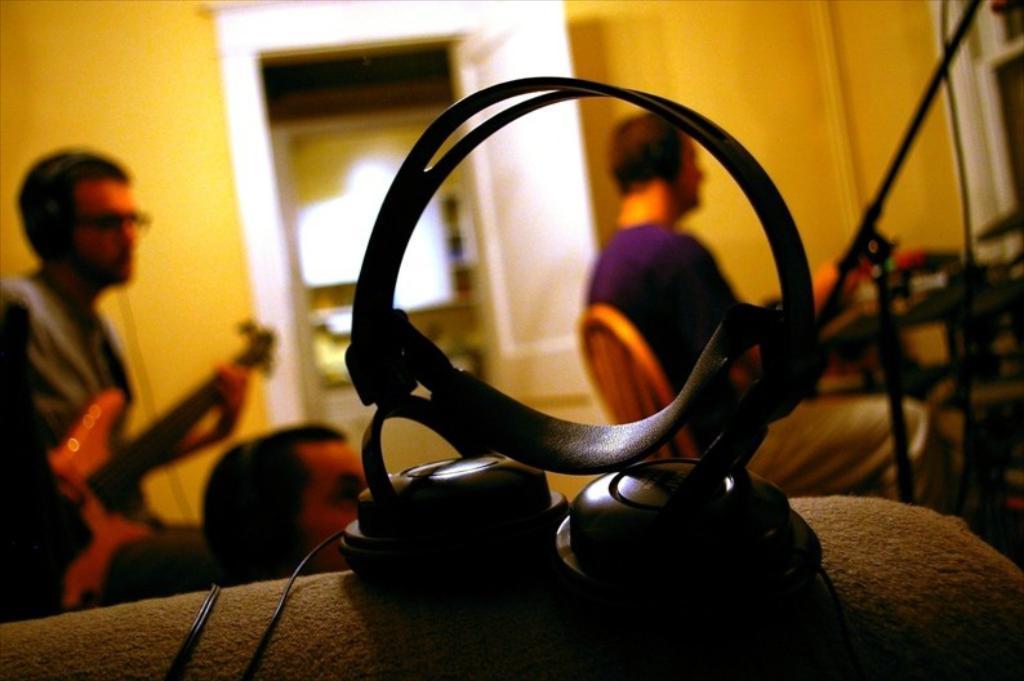How would you summarize this image in a sentence or two? There is a headset. 3 people are present in a room. A person is playing guitar at the left. There is a white door at the back. 